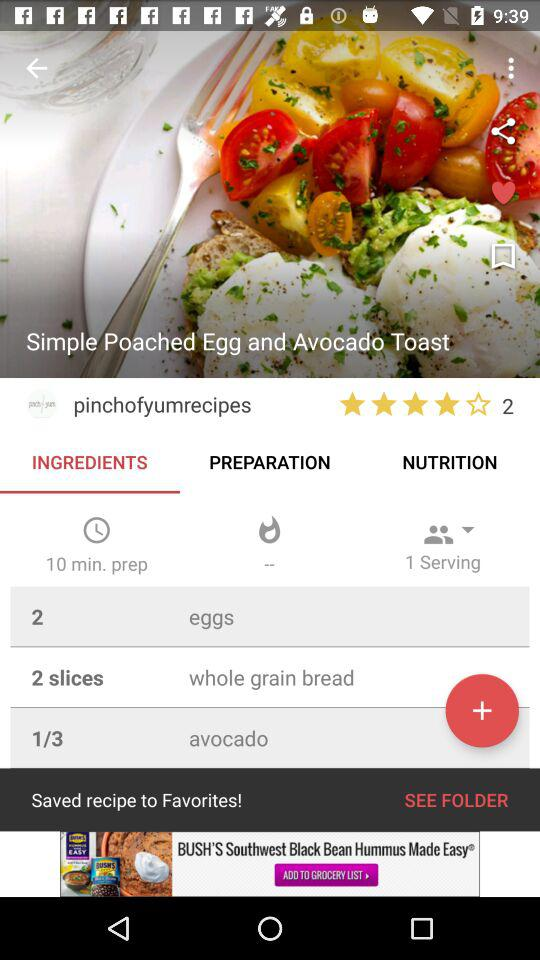How long does it take to prepare the dish?
When the provided information is insufficient, respond with <no answer>. <no answer> 